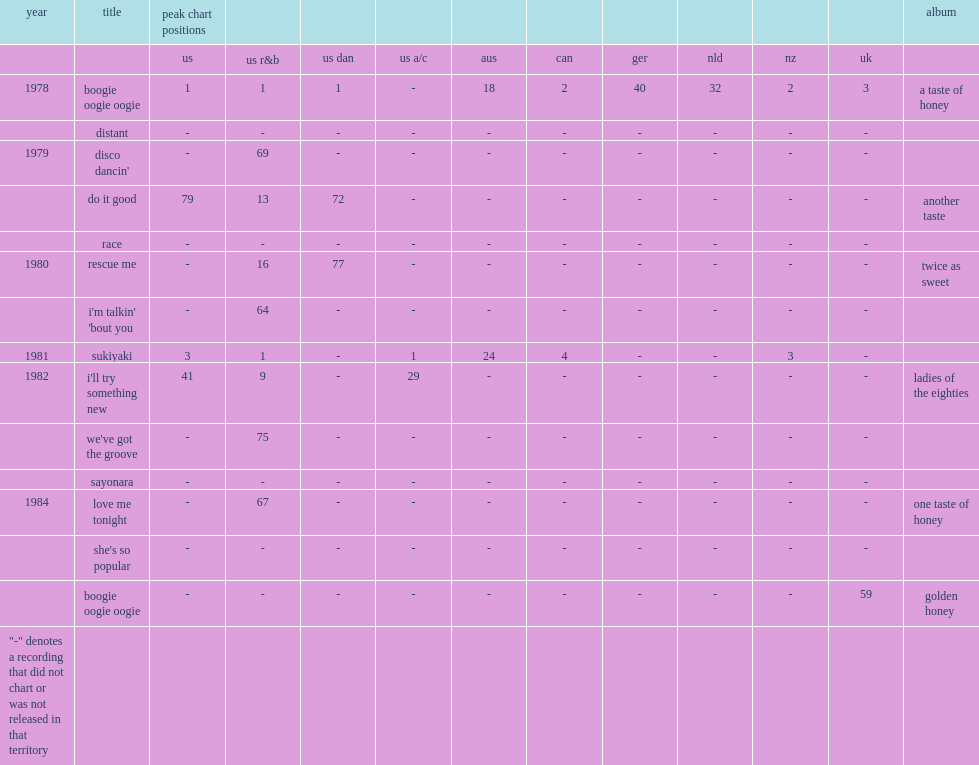When is the first single, "boogie oogie oogie", from a taste of honey's debut album a taste of honey released? 1978.0. 